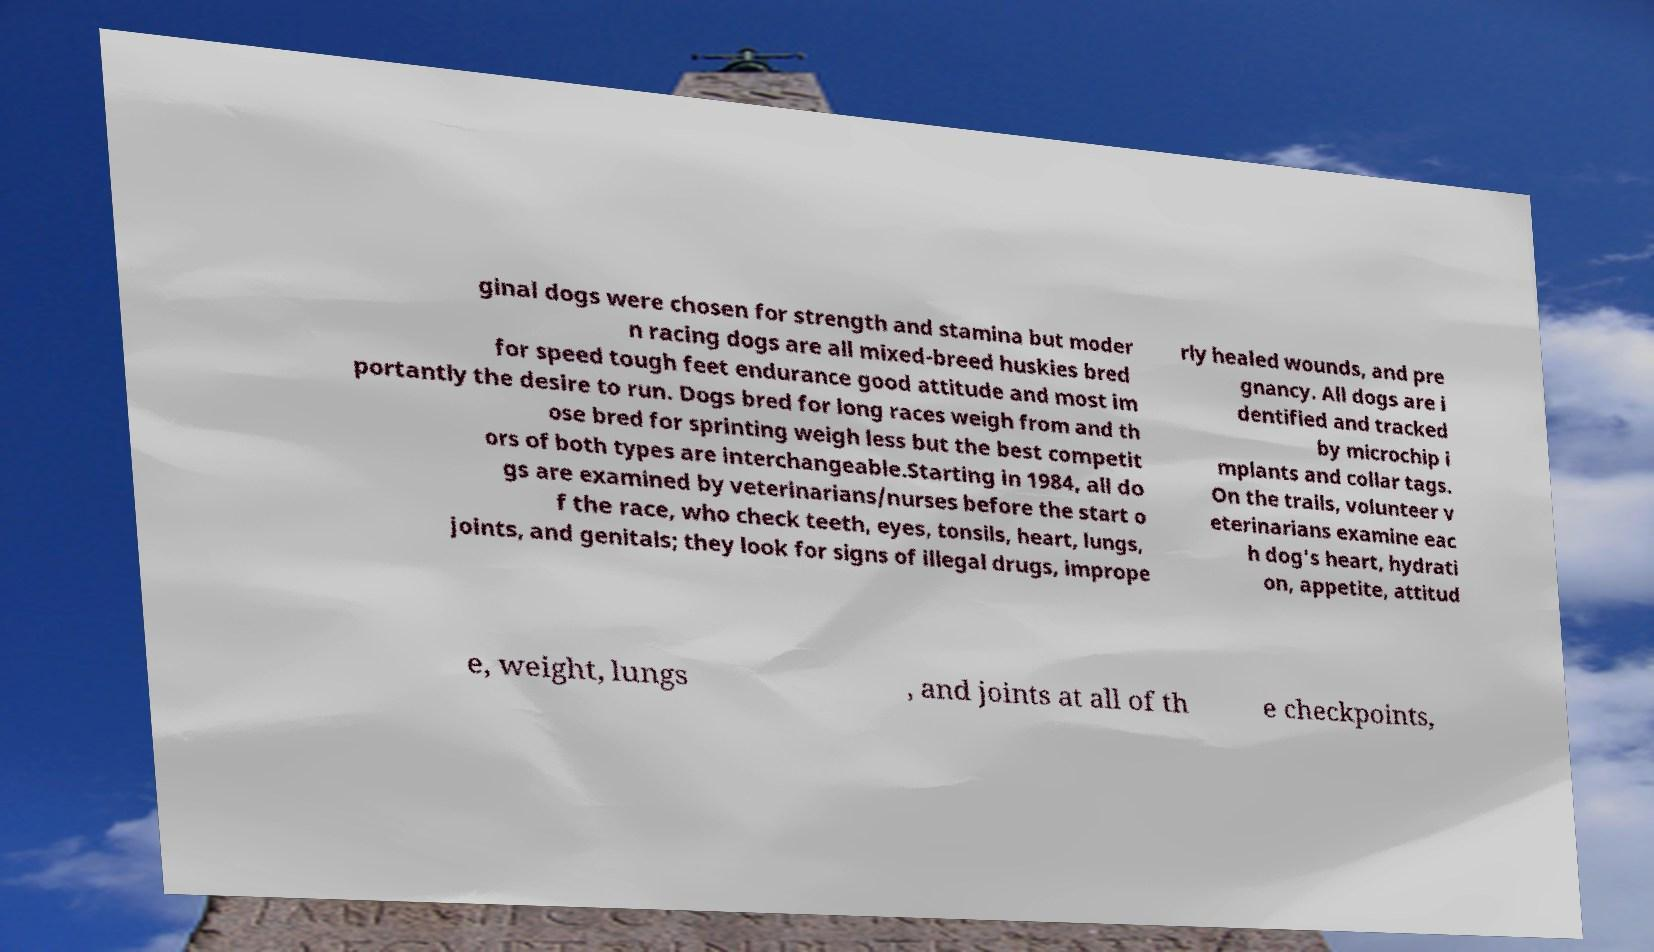Could you assist in decoding the text presented in this image and type it out clearly? ginal dogs were chosen for strength and stamina but moder n racing dogs are all mixed-breed huskies bred for speed tough feet endurance good attitude and most im portantly the desire to run. Dogs bred for long races weigh from and th ose bred for sprinting weigh less but the best competit ors of both types are interchangeable.Starting in 1984, all do gs are examined by veterinarians/nurses before the start o f the race, who check teeth, eyes, tonsils, heart, lungs, joints, and genitals; they look for signs of illegal drugs, imprope rly healed wounds, and pre gnancy. All dogs are i dentified and tracked by microchip i mplants and collar tags. On the trails, volunteer v eterinarians examine eac h dog's heart, hydrati on, appetite, attitud e, weight, lungs , and joints at all of th e checkpoints, 